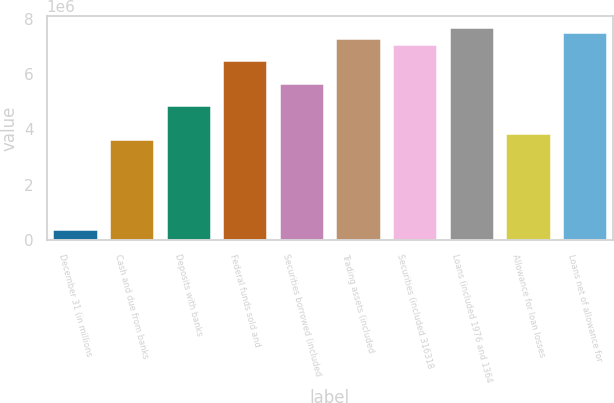Convert chart to OTSL. <chart><loc_0><loc_0><loc_500><loc_500><bar_chart><fcel>December 31 (in millions<fcel>Cash and due from banks<fcel>Deposits with banks<fcel>Federal funds sold and<fcel>Securities borrowed (included<fcel>Trading assets (included<fcel>Securities (included 316318<fcel>Loans (included 1976 and 1364<fcel>Allowance for loan losses<fcel>Loans net of allowance for<nl><fcel>406452<fcel>3.65753e+06<fcel>4.87668e+06<fcel>6.50222e+06<fcel>5.68945e+06<fcel>7.31498e+06<fcel>7.11179e+06<fcel>7.72137e+06<fcel>3.86072e+06<fcel>7.51818e+06<nl></chart> 